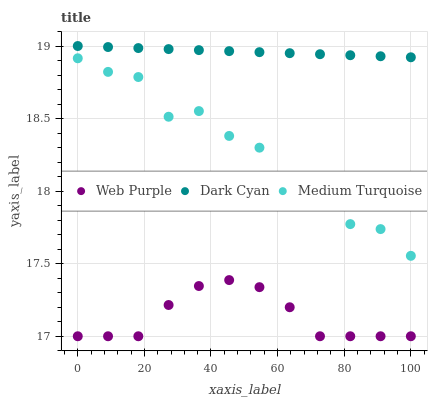Does Web Purple have the minimum area under the curve?
Answer yes or no. Yes. Does Dark Cyan have the maximum area under the curve?
Answer yes or no. Yes. Does Medium Turquoise have the minimum area under the curve?
Answer yes or no. No. Does Medium Turquoise have the maximum area under the curve?
Answer yes or no. No. Is Dark Cyan the smoothest?
Answer yes or no. Yes. Is Medium Turquoise the roughest?
Answer yes or no. Yes. Is Web Purple the smoothest?
Answer yes or no. No. Is Web Purple the roughest?
Answer yes or no. No. Does Web Purple have the lowest value?
Answer yes or no. Yes. Does Medium Turquoise have the lowest value?
Answer yes or no. No. Does Dark Cyan have the highest value?
Answer yes or no. Yes. Does Medium Turquoise have the highest value?
Answer yes or no. No. Is Web Purple less than Medium Turquoise?
Answer yes or no. Yes. Is Dark Cyan greater than Web Purple?
Answer yes or no. Yes. Does Web Purple intersect Medium Turquoise?
Answer yes or no. No. 